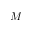Convert formula to latex. <formula><loc_0><loc_0><loc_500><loc_500>M</formula> 